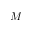Convert formula to latex. <formula><loc_0><loc_0><loc_500><loc_500>M</formula> 